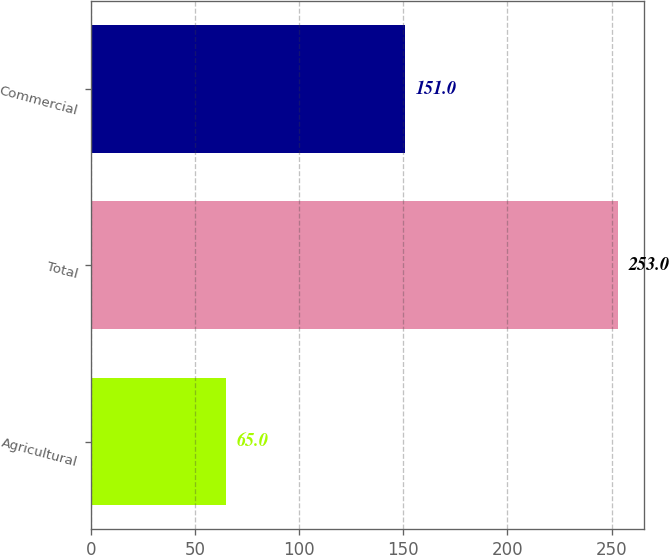Convert chart. <chart><loc_0><loc_0><loc_500><loc_500><bar_chart><fcel>Agricultural<fcel>Total<fcel>Commercial<nl><fcel>65<fcel>253<fcel>151<nl></chart> 